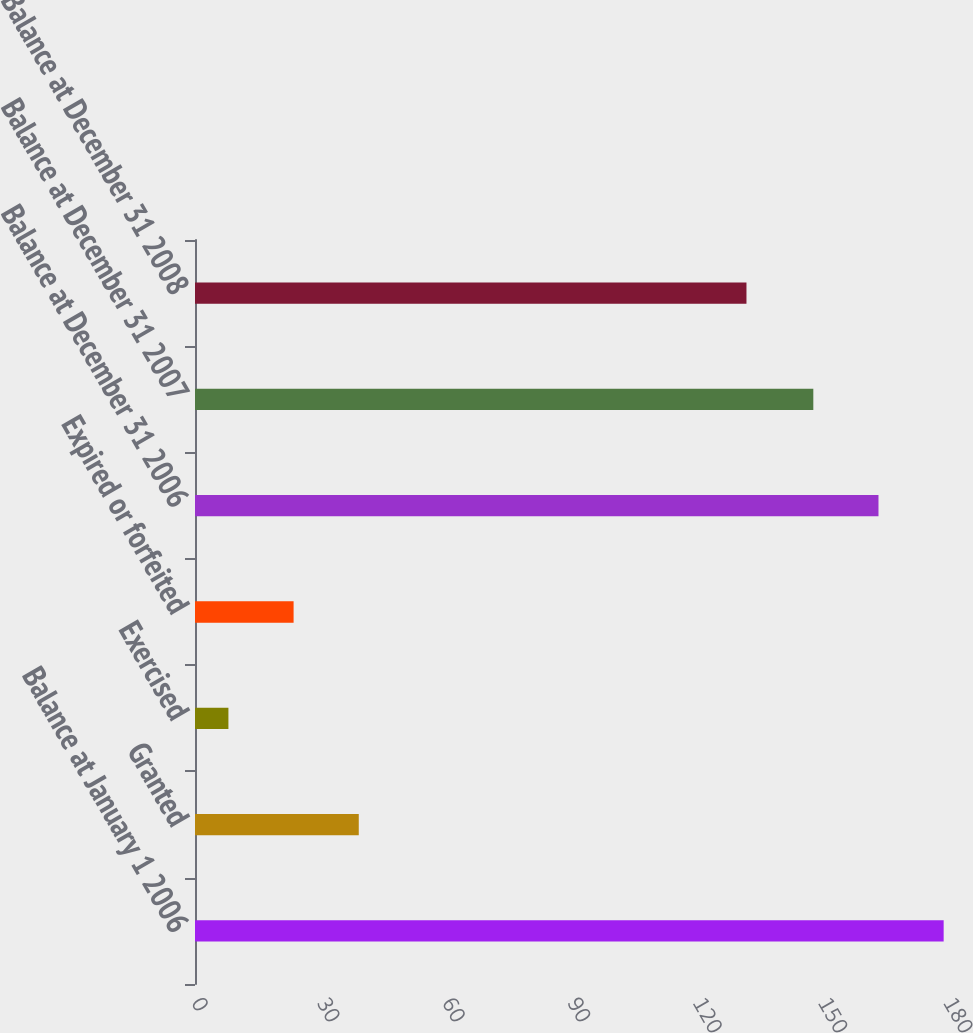<chart> <loc_0><loc_0><loc_500><loc_500><bar_chart><fcel>Balance at January 1 2006<fcel>Granted<fcel>Exercised<fcel>Expired or forfeited<fcel>Balance at December 31 2006<fcel>Balance at December 31 2007<fcel>Balance at December 31 2008<nl><fcel>179.2<fcel>39.2<fcel>8<fcel>23.6<fcel>163.6<fcel>148<fcel>132<nl></chart> 